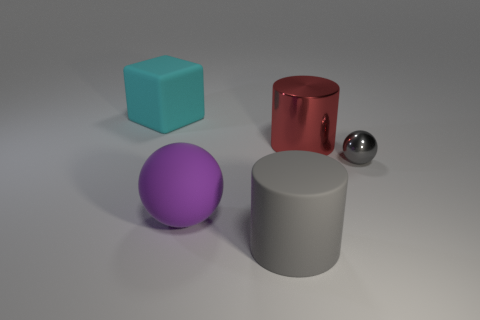Subtract all purple spheres. How many spheres are left? 1 Subtract all blocks. How many objects are left? 4 Subtract 1 cylinders. How many cylinders are left? 1 Add 2 big metal things. How many objects exist? 7 Add 3 gray matte things. How many gray matte things are left? 4 Add 2 large gray matte things. How many large gray matte things exist? 3 Subtract 0 brown cylinders. How many objects are left? 5 Subtract all red cylinders. Subtract all brown balls. How many cylinders are left? 1 Subtract all red blocks. How many red cylinders are left? 1 Subtract all large gray things. Subtract all tiny brown matte objects. How many objects are left? 4 